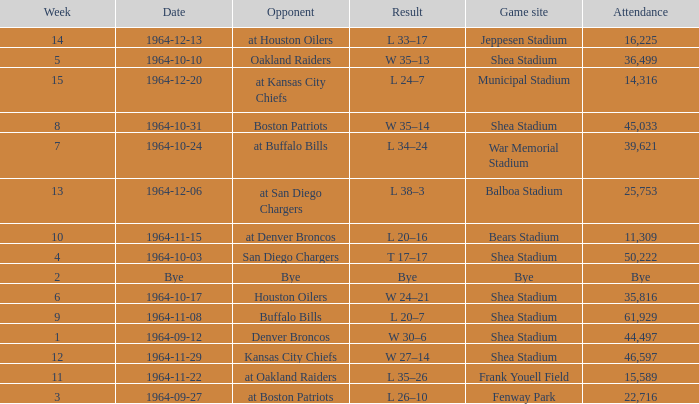What's the result of the game against Bye? Bye. 